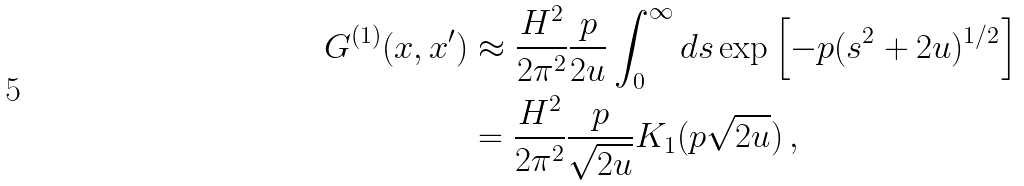Convert formula to latex. <formula><loc_0><loc_0><loc_500><loc_500>G ^ { ( 1 ) } ( x , x ^ { \prime } ) & \approx \frac { H ^ { 2 } } { 2 \pi ^ { 2 } } \frac { p } { 2 u } \int _ { 0 } ^ { \infty } d s \exp \left [ - p ( s ^ { 2 } + 2 u ) ^ { 1 / 2 } \right ] \\ & = \frac { H ^ { 2 } } { 2 \pi ^ { 2 } } \frac { p } { \sqrt { 2 u } } K _ { 1 } ( p \sqrt { 2 u } ) \, ,</formula> 